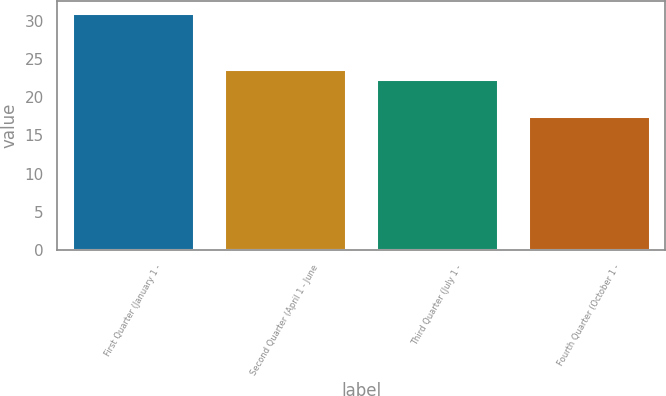Convert chart to OTSL. <chart><loc_0><loc_0><loc_500><loc_500><bar_chart><fcel>First Quarter (January 1 -<fcel>Second Quarter (April 1 - June<fcel>Third Quarter (July 1 -<fcel>Fourth Quarter (October 1 -<nl><fcel>31.06<fcel>23.71<fcel>22.37<fcel>17.61<nl></chart> 